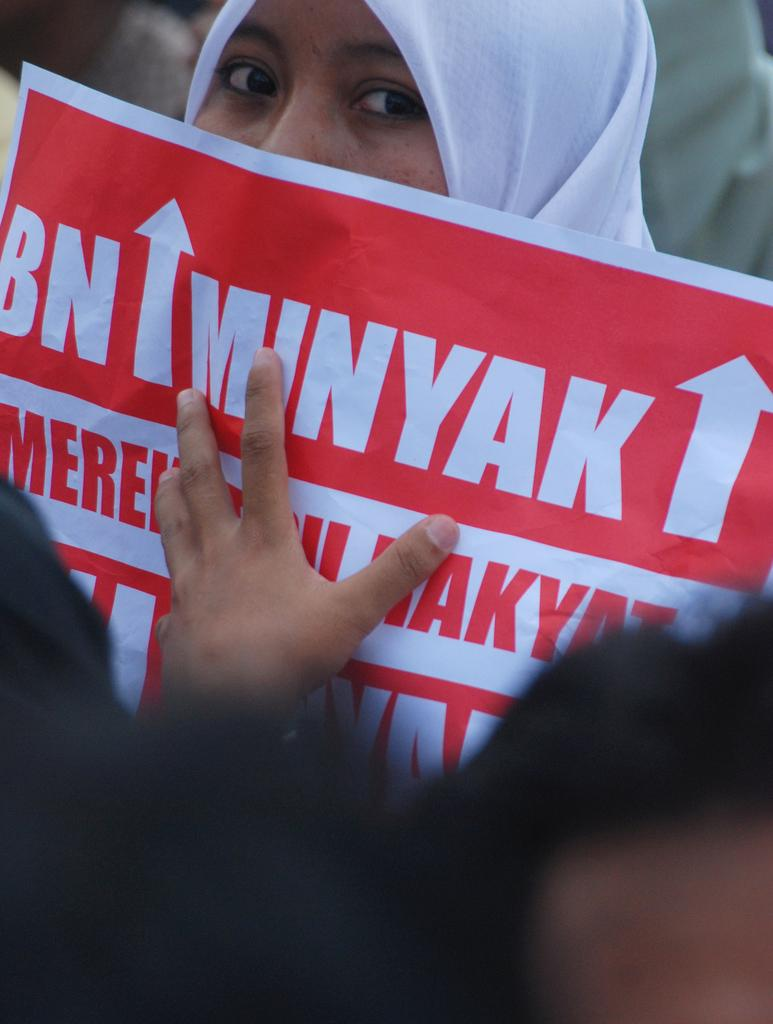Who is in the image? There is a person in the image. What is the person holding? The person is holding a paper. What colors are present on the paper? The paper has red and white colors. What can be seen on the paper besides the colors? There is writing on the paper. What time is displayed on the clock in the image? There is no clock present in the image. What items are on the list in the image? There is no list present in the image. 